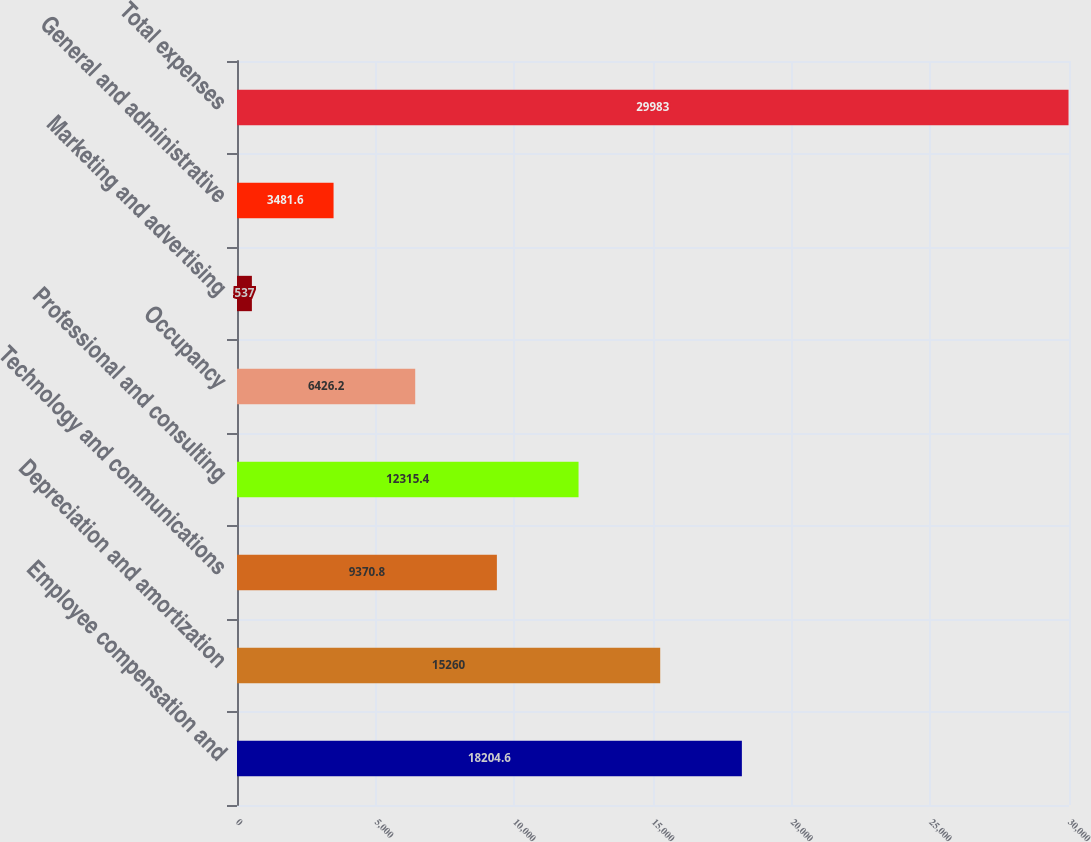Convert chart. <chart><loc_0><loc_0><loc_500><loc_500><bar_chart><fcel>Employee compensation and<fcel>Depreciation and amortization<fcel>Technology and communications<fcel>Professional and consulting<fcel>Occupancy<fcel>Marketing and advertising<fcel>General and administrative<fcel>Total expenses<nl><fcel>18204.6<fcel>15260<fcel>9370.8<fcel>12315.4<fcel>6426.2<fcel>537<fcel>3481.6<fcel>29983<nl></chart> 